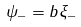Convert formula to latex. <formula><loc_0><loc_0><loc_500><loc_500>\psi _ { - } = b \xi _ { - }</formula> 